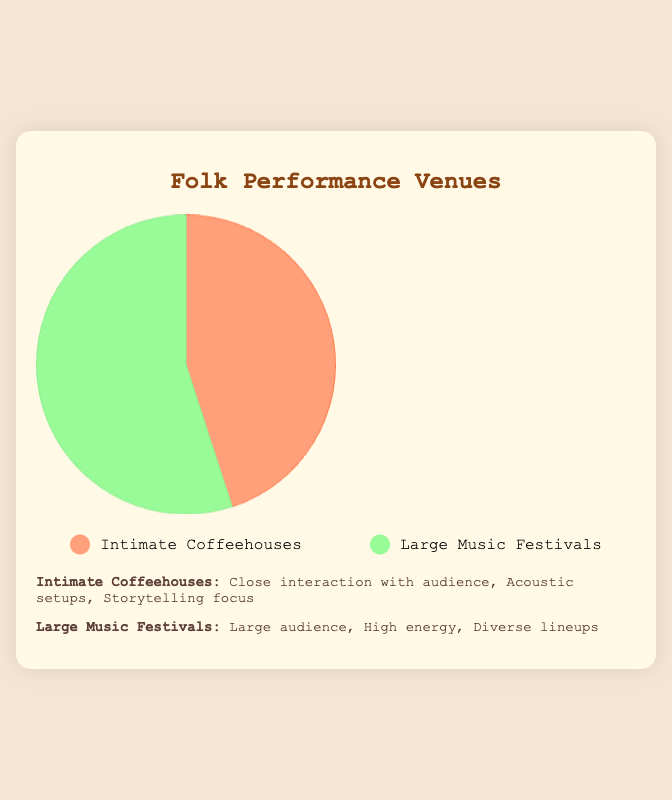Which type of venue represents the largest percentage? Looking at the pie chart, the section representing Large Music Festivals is larger. It occupies 55% while Intimate Coffeehouses occupies 45%.
Answer: Large Music Festivals What percentage of venues are Intimate Coffeehouses? From the pie chart, we can see that the section for Intimate Coffeehouses is labeled with 45%.
Answer: 45% How much larger is the percentage of Large Music Festivals compared to Intimate Coffeehouses? Large Music Festivals have a percentage of 55%, and Intimate Coffeehouses have 45%. The difference is 55% - 45% = 10%.
Answer: 10% What is the combined percentage of both types of venues? The sum of the percentages for Intimate Coffeehouses and Large Music Festivals is 45% + 55%. This equals 100%.
Answer: 100% Which venue type has a higher focus on close interaction with the audience? The description provided under the pie chart states that Intimate Coffeehouses feature close interaction with the audience.
Answer: Intimate Coffeehouses Identify the segment in the pie chart that is colored green. What type of venue does it represent? The legend shows that the green color corresponds to Large Music Festivals.
Answer: Large Music Festivals How do the acoustic setups differ between the two venue types? According to the features listed, Intimate Coffeehouses have acoustic setups, while this feature is not mentioned for Large Music Festivals, which focus on high energy.
Answer: Intimate Coffeehouses What is the visual difference between the segment representing Intimate Coffeehouses and the one representing Large Music Festivals? Visually, the segment for Intimate Coffeehouses is colored orange and occupies 45%, whereas the segment for Large Music Festivals is colored green and occupies 55%.
Answer: Color and Percentage Which venue would you expect to offer more diverse musical lineups? The description under the pie chart mentions that Large Music Festivals feature diverse lineups.
Answer: Large Music Festivals 